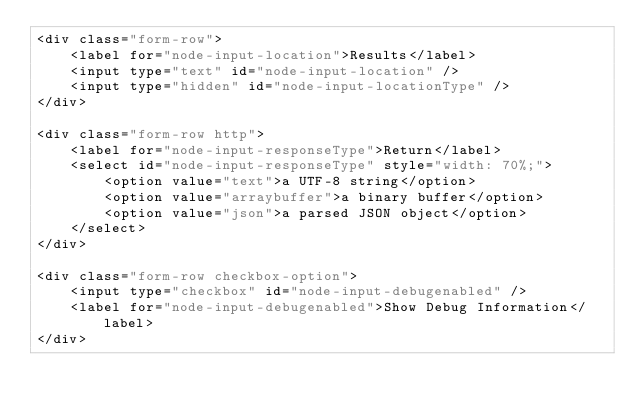<code> <loc_0><loc_0><loc_500><loc_500><_HTML_><div class="form-row">
    <label for="node-input-location">Results</label>
    <input type="text" id="node-input-location" />
    <input type="hidden" id="node-input-locationType" />
</div>

<div class="form-row http">
    <label for="node-input-responseType">Return</label>
    <select id="node-input-responseType" style="width: 70%;">
        <option value="text">a UTF-8 string</option>
        <option value="arraybuffer">a binary buffer</option>
        <option value="json">a parsed JSON object</option>
    </select>
</div>

<div class="form-row checkbox-option">
    <input type="checkbox" id="node-input-debugenabled" />
    <label for="node-input-debugenabled">Show Debug Information</label>
</div>
</code> 